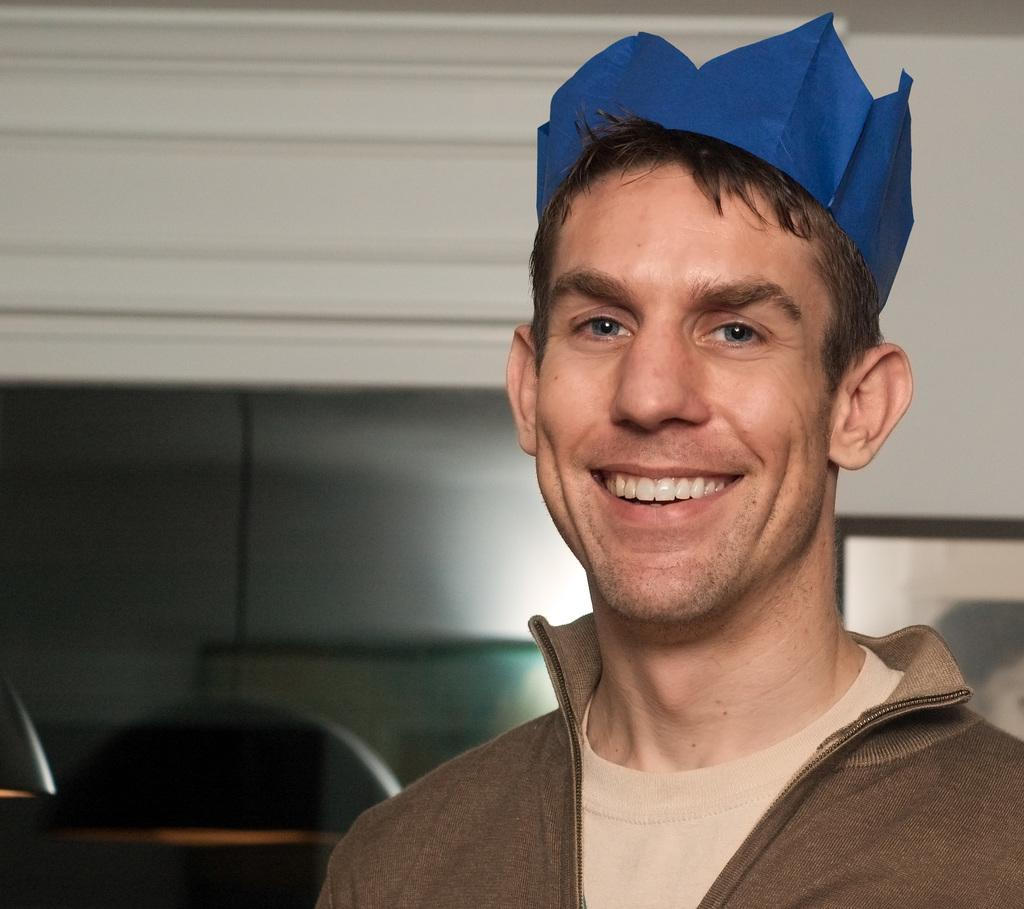Who or what is the main subject in the image? There is a person in the center of the image. What is the person wearing on their head? The person is wearing a blue color crown. What type of clothing is the person wearing on their upper body? The person is wearing a brown color jacket. What can be seen behind the person in the image? There is a wall in the background of the image. Is there a volcano erupting in the background of the image? No, there is no volcano present in the image. Can you tell me how many experts are visible in the image? There are no experts mentioned or visible in the image; it features a person wearing a crown and jacket. 